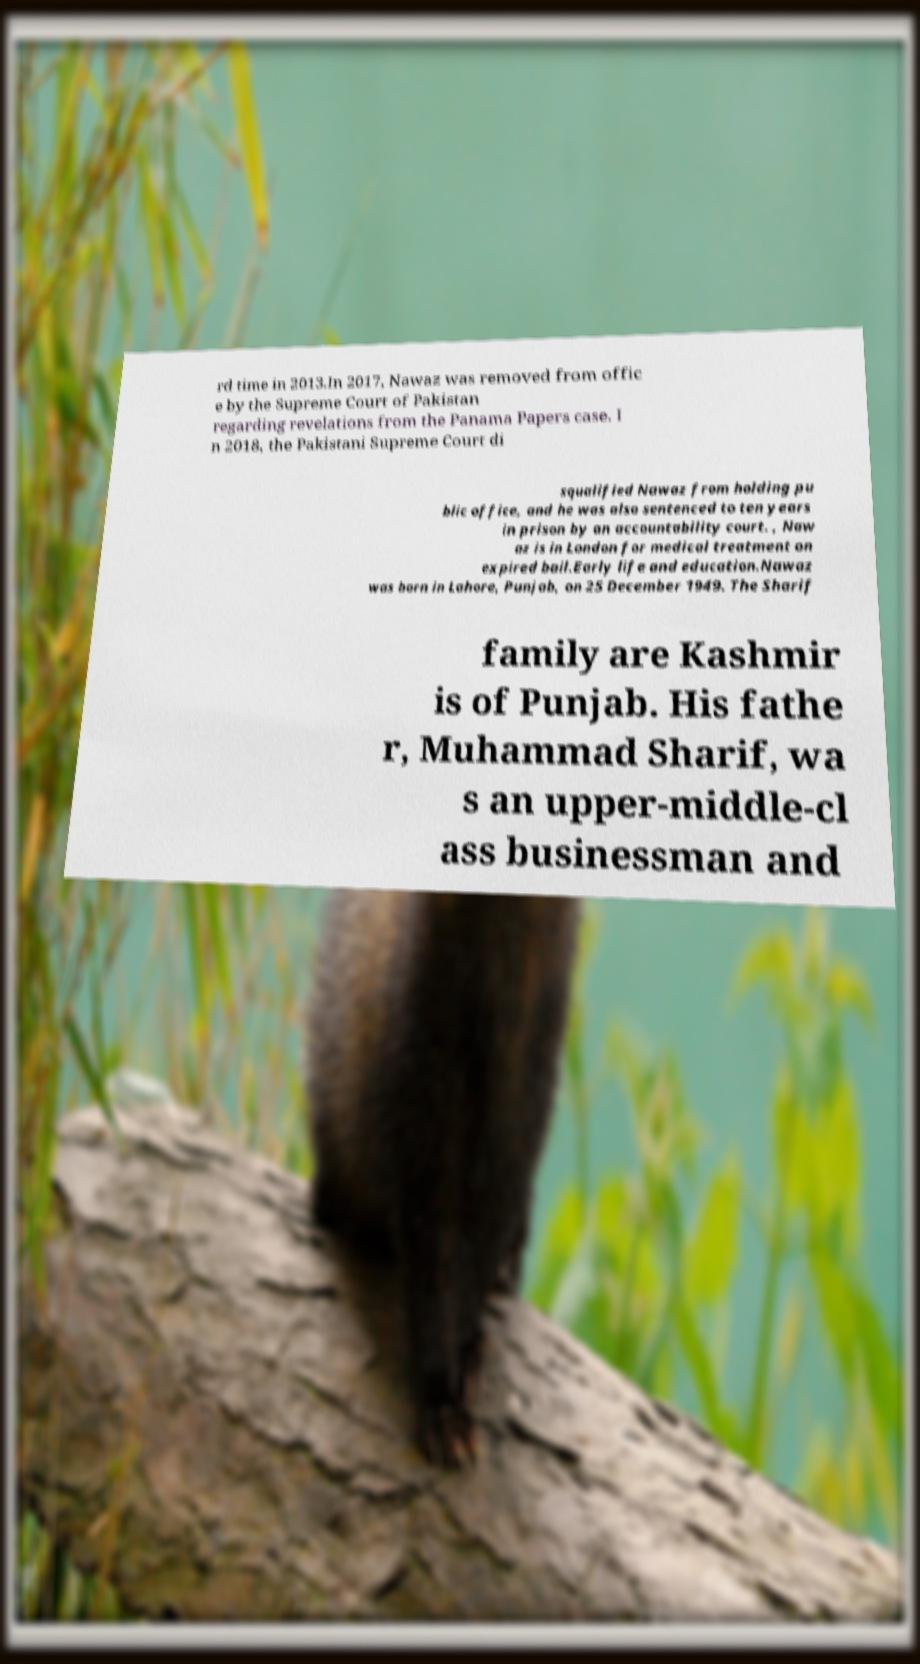For documentation purposes, I need the text within this image transcribed. Could you provide that? rd time in 2013.In 2017, Nawaz was removed from offic e by the Supreme Court of Pakistan regarding revelations from the Panama Papers case. I n 2018, the Pakistani Supreme Court di squalified Nawaz from holding pu blic office, and he was also sentenced to ten years in prison by an accountability court. , Naw az is in London for medical treatment on expired bail.Early life and education.Nawaz was born in Lahore, Punjab, on 25 December 1949. The Sharif family are Kashmir is of Punjab. His fathe r, Muhammad Sharif, wa s an upper-middle-cl ass businessman and 